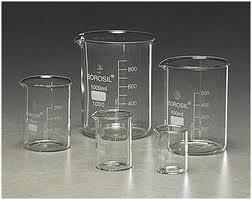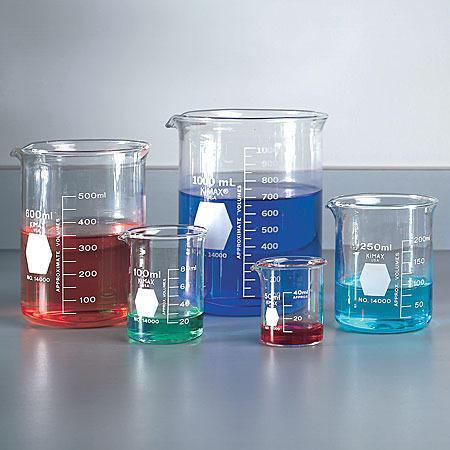The first image is the image on the left, the second image is the image on the right. Considering the images on both sides, is "At least 7 beakers of varying sizes are filled with colorful liquid." valid? Answer yes or no. No. The first image is the image on the left, the second image is the image on the right. Analyze the images presented: Is the assertion "The left and right image contains a total of eight beakers." valid? Answer yes or no. No. 